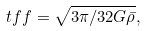Convert formula to latex. <formula><loc_0><loc_0><loc_500><loc_500>\ t f f = \sqrt { 3 \pi / 3 2 G \bar { \rho } } ,</formula> 